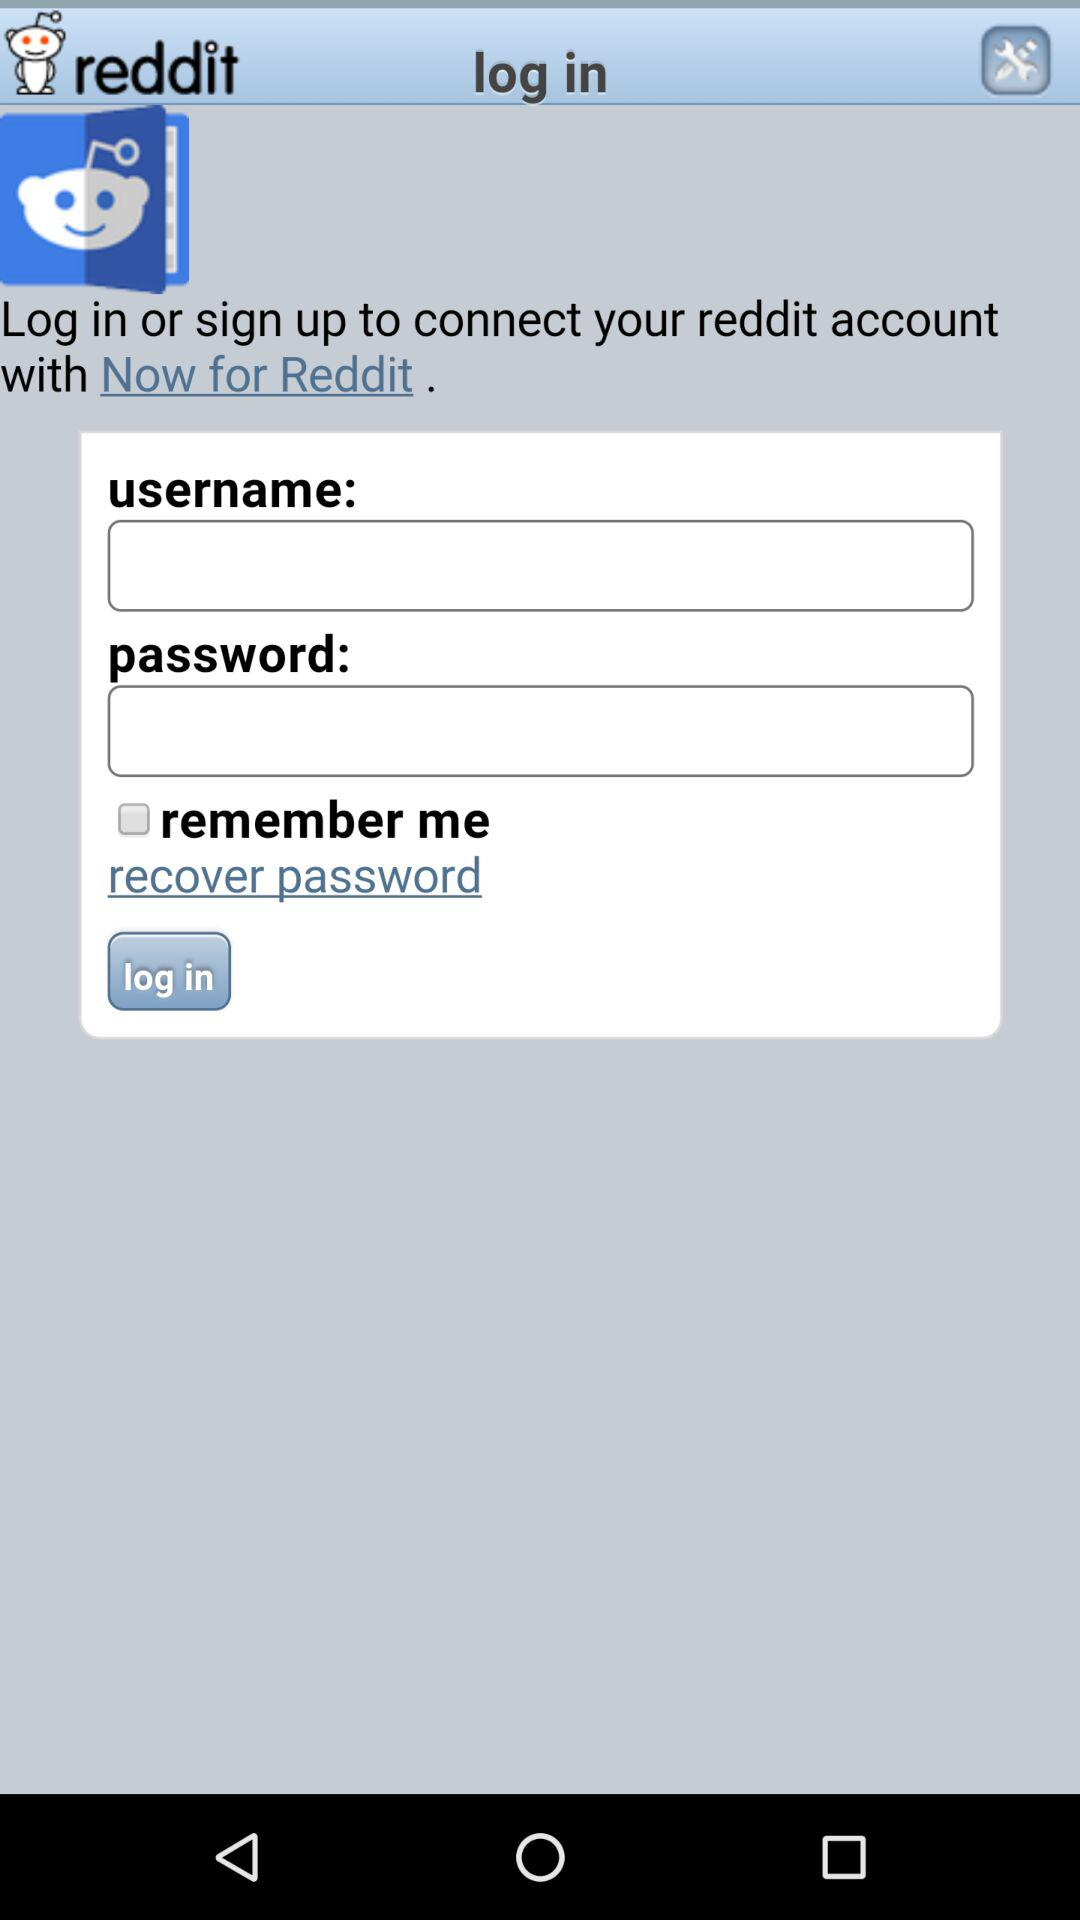What is the name of the application? The name of the application is "reddit". 